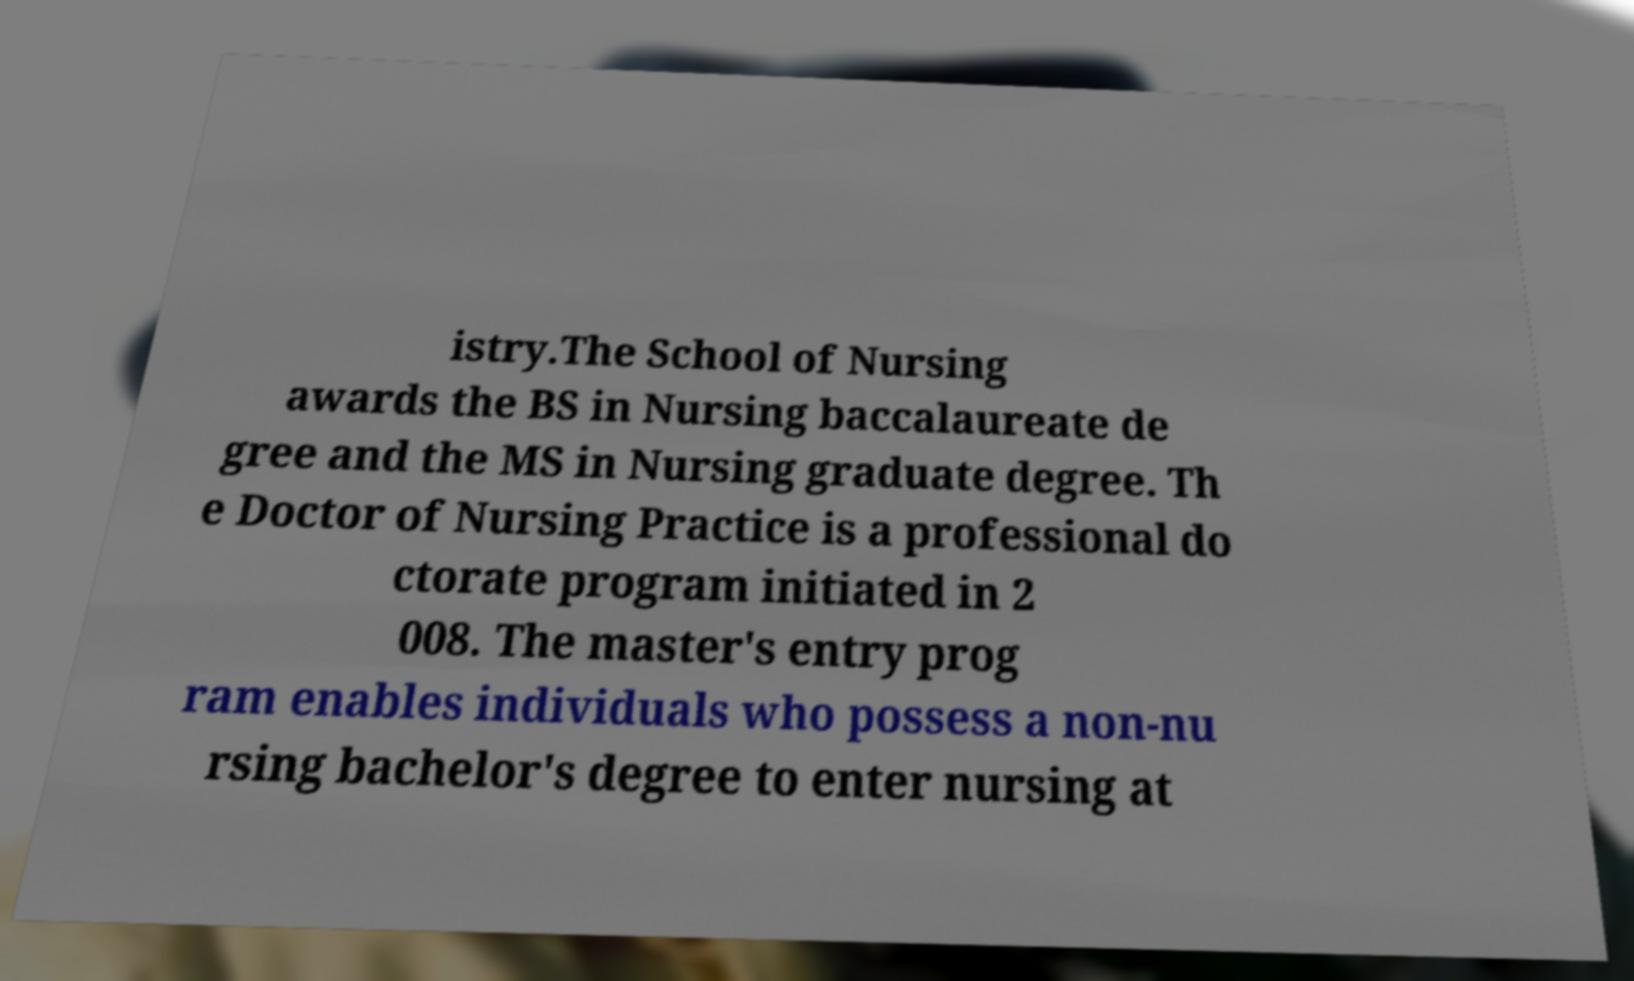Can you read and provide the text displayed in the image?This photo seems to have some interesting text. Can you extract and type it out for me? istry.The School of Nursing awards the BS in Nursing baccalaureate de gree and the MS in Nursing graduate degree. Th e Doctor of Nursing Practice is a professional do ctorate program initiated in 2 008. The master's entry prog ram enables individuals who possess a non-nu rsing bachelor's degree to enter nursing at 